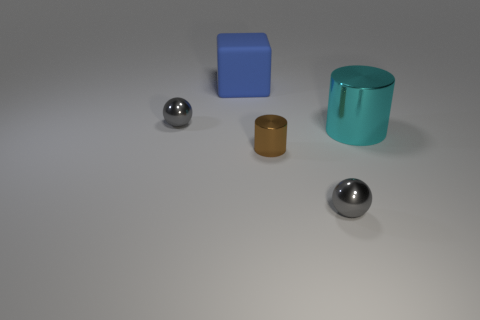What number of other things are there of the same material as the cyan object
Offer a very short reply. 3. How many things are small metal blocks or tiny gray shiny objects?
Give a very brief answer. 2. Are there more small gray balls behind the brown thing than blue rubber cubes that are on the right side of the block?
Provide a short and direct response. Yes. There is a metallic object that is behind the large cyan object; is it the same color as the tiny sphere on the right side of the blue block?
Make the answer very short. Yes. What size is the blue rubber block behind the big object in front of the tiny object on the left side of the blue block?
Offer a terse response. Large. What is the color of the other thing that is the same shape as the cyan metallic object?
Give a very brief answer. Brown. Are there more gray objects behind the cyan shiny cylinder than small yellow objects?
Offer a very short reply. Yes. Is the shape of the tiny brown thing the same as the large thing in front of the large cube?
Provide a short and direct response. Yes. There is another thing that is the same shape as the big metal thing; what size is it?
Give a very brief answer. Small. Is the number of small gray spheres greater than the number of tiny metallic objects?
Your answer should be compact. No. 